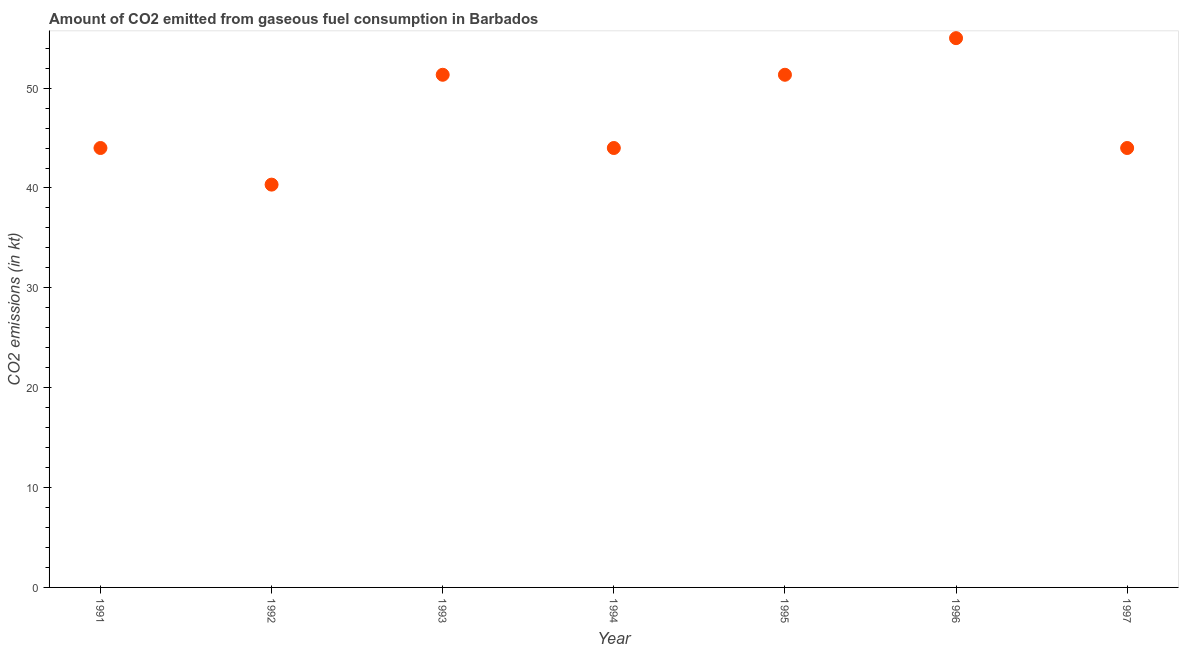What is the co2 emissions from gaseous fuel consumption in 1995?
Ensure brevity in your answer.  51.34. Across all years, what is the maximum co2 emissions from gaseous fuel consumption?
Offer a very short reply. 55.01. Across all years, what is the minimum co2 emissions from gaseous fuel consumption?
Make the answer very short. 40.34. In which year was the co2 emissions from gaseous fuel consumption maximum?
Keep it short and to the point. 1996. What is the sum of the co2 emissions from gaseous fuel consumption?
Provide a short and direct response. 330.03. What is the difference between the co2 emissions from gaseous fuel consumption in 1994 and 1996?
Offer a terse response. -11. What is the average co2 emissions from gaseous fuel consumption per year?
Your answer should be compact. 47.15. What is the median co2 emissions from gaseous fuel consumption?
Keep it short and to the point. 44. Do a majority of the years between 1996 and 1991 (inclusive) have co2 emissions from gaseous fuel consumption greater than 14 kt?
Provide a succinct answer. Yes. What is the ratio of the co2 emissions from gaseous fuel consumption in 1995 to that in 1997?
Provide a succinct answer. 1.17. Is the co2 emissions from gaseous fuel consumption in 1994 less than that in 1996?
Keep it short and to the point. Yes. What is the difference between the highest and the second highest co2 emissions from gaseous fuel consumption?
Provide a short and direct response. 3.67. What is the difference between the highest and the lowest co2 emissions from gaseous fuel consumption?
Make the answer very short. 14.67. How many years are there in the graph?
Make the answer very short. 7. Does the graph contain grids?
Provide a succinct answer. No. What is the title of the graph?
Your answer should be compact. Amount of CO2 emitted from gaseous fuel consumption in Barbados. What is the label or title of the Y-axis?
Offer a terse response. CO2 emissions (in kt). What is the CO2 emissions (in kt) in 1991?
Provide a short and direct response. 44. What is the CO2 emissions (in kt) in 1992?
Your answer should be compact. 40.34. What is the CO2 emissions (in kt) in 1993?
Give a very brief answer. 51.34. What is the CO2 emissions (in kt) in 1994?
Ensure brevity in your answer.  44. What is the CO2 emissions (in kt) in 1995?
Give a very brief answer. 51.34. What is the CO2 emissions (in kt) in 1996?
Provide a short and direct response. 55.01. What is the CO2 emissions (in kt) in 1997?
Make the answer very short. 44. What is the difference between the CO2 emissions (in kt) in 1991 and 1992?
Provide a short and direct response. 3.67. What is the difference between the CO2 emissions (in kt) in 1991 and 1993?
Make the answer very short. -7.33. What is the difference between the CO2 emissions (in kt) in 1991 and 1995?
Offer a terse response. -7.33. What is the difference between the CO2 emissions (in kt) in 1991 and 1996?
Keep it short and to the point. -11. What is the difference between the CO2 emissions (in kt) in 1992 and 1993?
Offer a very short reply. -11. What is the difference between the CO2 emissions (in kt) in 1992 and 1994?
Give a very brief answer. -3.67. What is the difference between the CO2 emissions (in kt) in 1992 and 1995?
Give a very brief answer. -11. What is the difference between the CO2 emissions (in kt) in 1992 and 1996?
Make the answer very short. -14.67. What is the difference between the CO2 emissions (in kt) in 1992 and 1997?
Provide a succinct answer. -3.67. What is the difference between the CO2 emissions (in kt) in 1993 and 1994?
Provide a short and direct response. 7.33. What is the difference between the CO2 emissions (in kt) in 1993 and 1995?
Ensure brevity in your answer.  0. What is the difference between the CO2 emissions (in kt) in 1993 and 1996?
Your answer should be very brief. -3.67. What is the difference between the CO2 emissions (in kt) in 1993 and 1997?
Provide a succinct answer. 7.33. What is the difference between the CO2 emissions (in kt) in 1994 and 1995?
Your response must be concise. -7.33. What is the difference between the CO2 emissions (in kt) in 1994 and 1996?
Your response must be concise. -11. What is the difference between the CO2 emissions (in kt) in 1995 and 1996?
Provide a succinct answer. -3.67. What is the difference between the CO2 emissions (in kt) in 1995 and 1997?
Give a very brief answer. 7.33. What is the difference between the CO2 emissions (in kt) in 1996 and 1997?
Provide a short and direct response. 11. What is the ratio of the CO2 emissions (in kt) in 1991 to that in 1992?
Offer a terse response. 1.09. What is the ratio of the CO2 emissions (in kt) in 1991 to that in 1993?
Give a very brief answer. 0.86. What is the ratio of the CO2 emissions (in kt) in 1991 to that in 1994?
Give a very brief answer. 1. What is the ratio of the CO2 emissions (in kt) in 1991 to that in 1995?
Your answer should be compact. 0.86. What is the ratio of the CO2 emissions (in kt) in 1991 to that in 1996?
Keep it short and to the point. 0.8. What is the ratio of the CO2 emissions (in kt) in 1991 to that in 1997?
Offer a terse response. 1. What is the ratio of the CO2 emissions (in kt) in 1992 to that in 1993?
Your answer should be compact. 0.79. What is the ratio of the CO2 emissions (in kt) in 1992 to that in 1994?
Make the answer very short. 0.92. What is the ratio of the CO2 emissions (in kt) in 1992 to that in 1995?
Your answer should be compact. 0.79. What is the ratio of the CO2 emissions (in kt) in 1992 to that in 1996?
Your response must be concise. 0.73. What is the ratio of the CO2 emissions (in kt) in 1992 to that in 1997?
Ensure brevity in your answer.  0.92. What is the ratio of the CO2 emissions (in kt) in 1993 to that in 1994?
Your answer should be compact. 1.17. What is the ratio of the CO2 emissions (in kt) in 1993 to that in 1996?
Give a very brief answer. 0.93. What is the ratio of the CO2 emissions (in kt) in 1993 to that in 1997?
Your answer should be very brief. 1.17. What is the ratio of the CO2 emissions (in kt) in 1994 to that in 1995?
Your response must be concise. 0.86. What is the ratio of the CO2 emissions (in kt) in 1994 to that in 1996?
Make the answer very short. 0.8. What is the ratio of the CO2 emissions (in kt) in 1994 to that in 1997?
Offer a terse response. 1. What is the ratio of the CO2 emissions (in kt) in 1995 to that in 1996?
Provide a succinct answer. 0.93. What is the ratio of the CO2 emissions (in kt) in 1995 to that in 1997?
Ensure brevity in your answer.  1.17. 